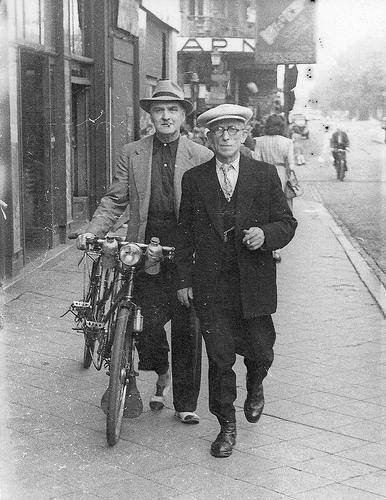How many men are wearing glasses?
Give a very brief answer. 1. 